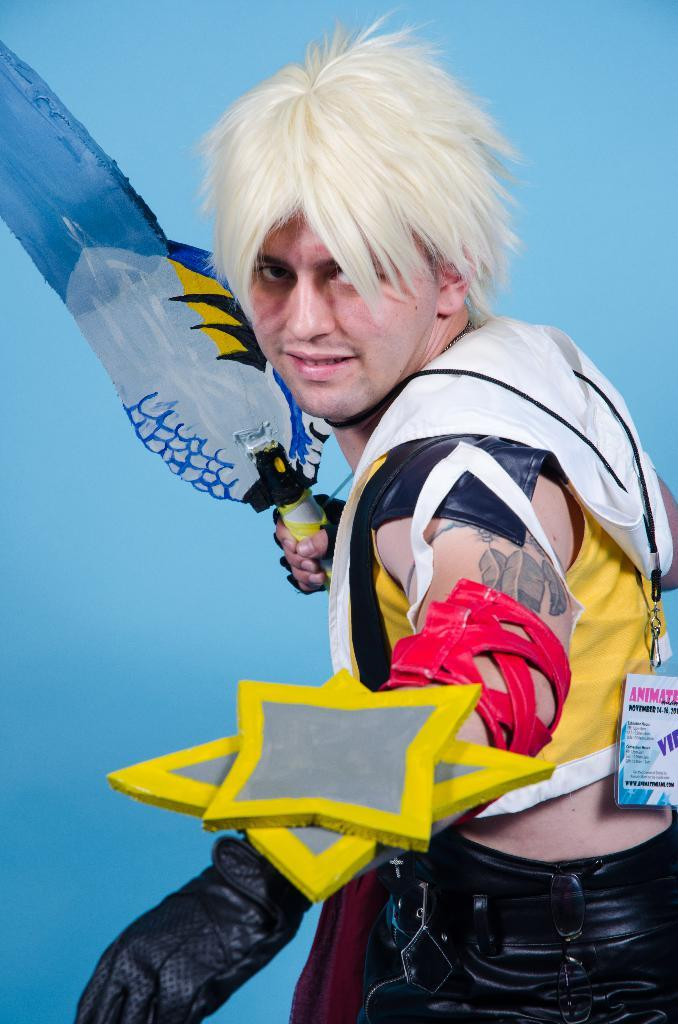What is present in the image? There is a person in the image. What is the person wearing? The person is wearing a costume. What object is the person holding? The person is holding a bat. What type of back support is the person using in the image? There is no indication of any back support in the image. How many thumbs does the person have on the hand holding the bat? The image does not show the person's thumb, so it cannot be determined from the image. 